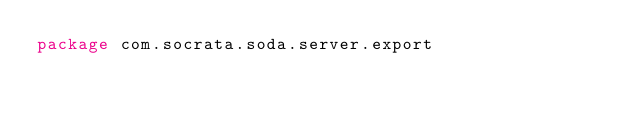<code> <loc_0><loc_0><loc_500><loc_500><_Scala_>package com.socrata.soda.server.export
</code> 